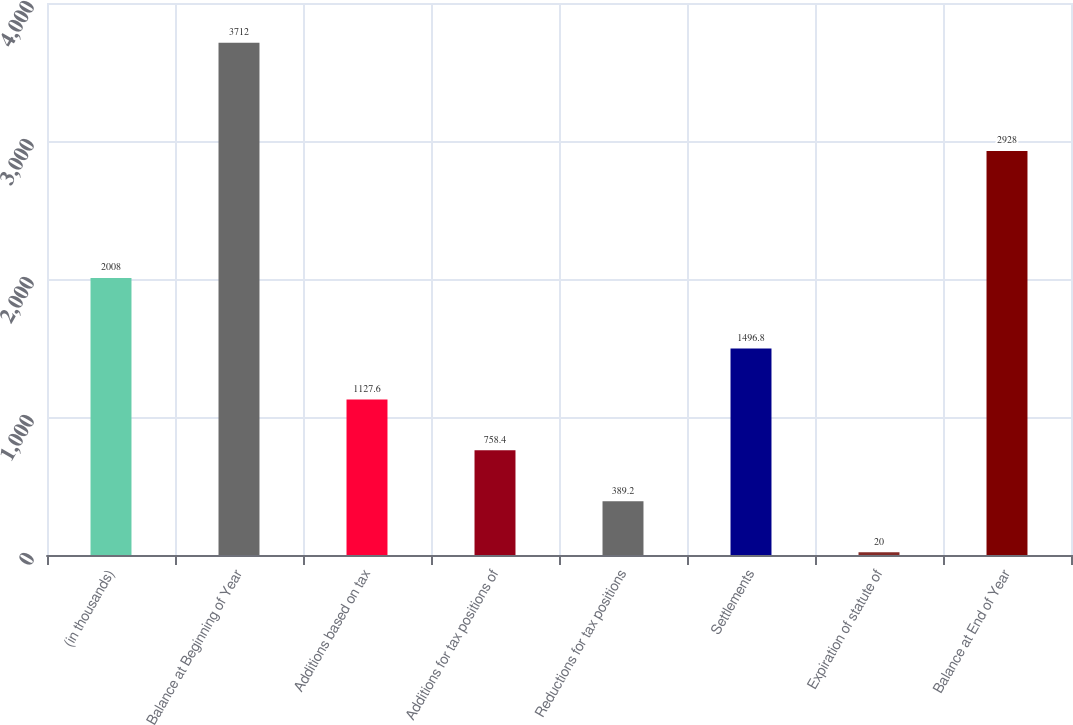Convert chart. <chart><loc_0><loc_0><loc_500><loc_500><bar_chart><fcel>(in thousands)<fcel>Balance at Beginning of Year<fcel>Additions based on tax<fcel>Additions for tax positions of<fcel>Reductions for tax positions<fcel>Settlements<fcel>Expiration of statute of<fcel>Balance at End of Year<nl><fcel>2008<fcel>3712<fcel>1127.6<fcel>758.4<fcel>389.2<fcel>1496.8<fcel>20<fcel>2928<nl></chart> 